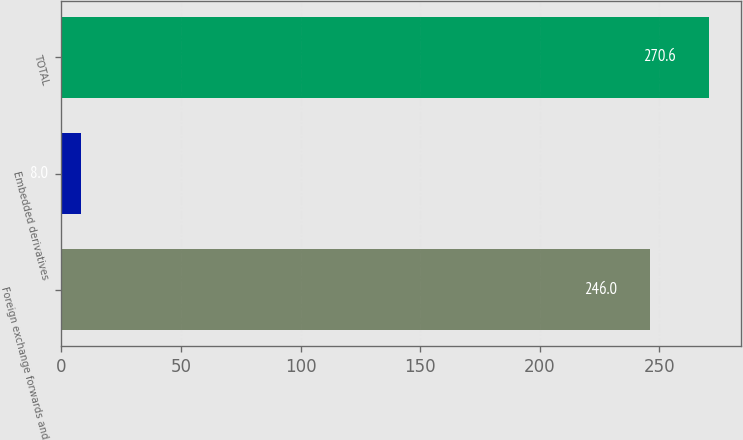<chart> <loc_0><loc_0><loc_500><loc_500><bar_chart><fcel>Foreign exchange forwards and<fcel>Embedded derivatives<fcel>TOTAL<nl><fcel>246<fcel>8<fcel>270.6<nl></chart> 